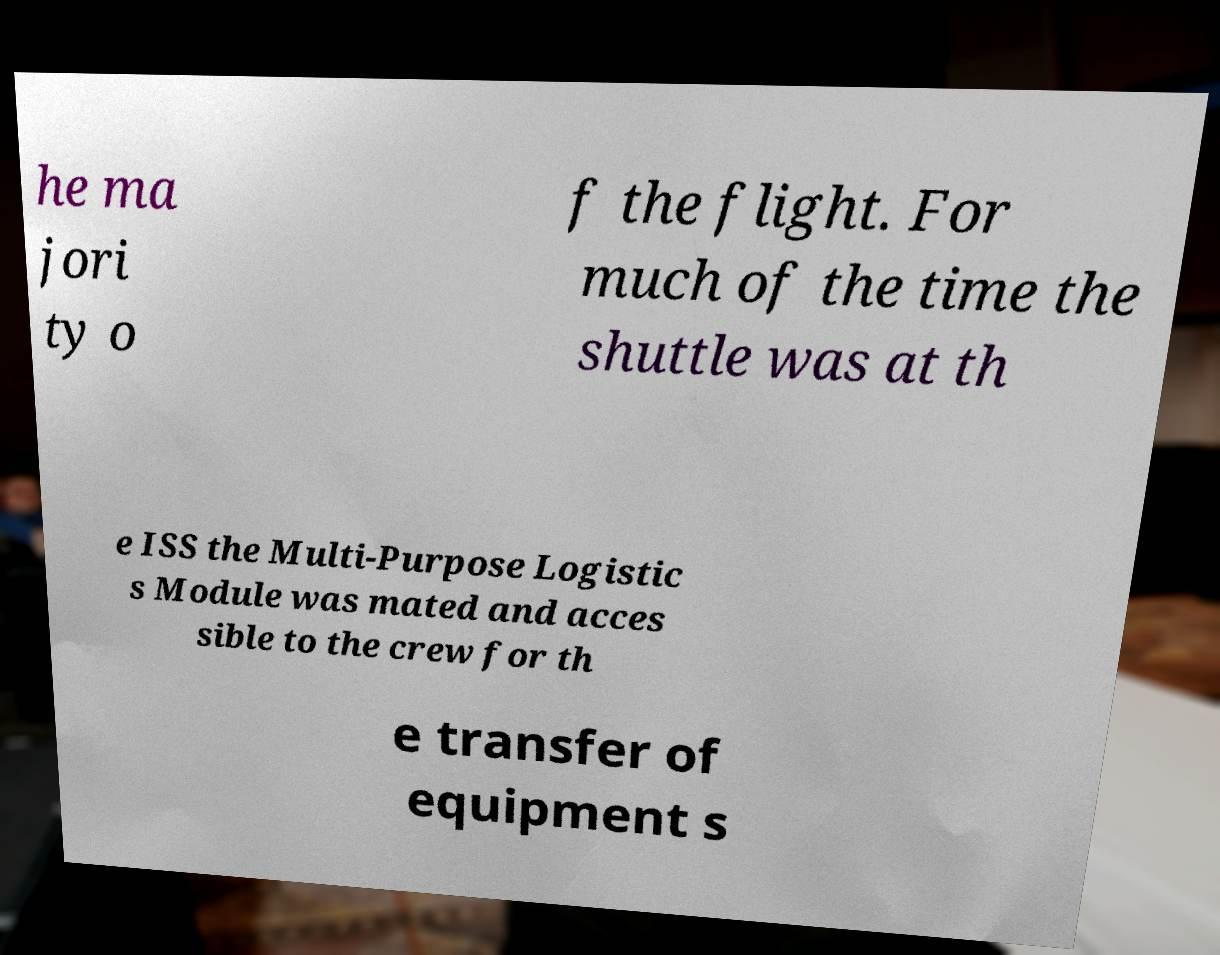Could you assist in decoding the text presented in this image and type it out clearly? he ma jori ty o f the flight. For much of the time the shuttle was at th e ISS the Multi-Purpose Logistic s Module was mated and acces sible to the crew for th e transfer of equipment s 